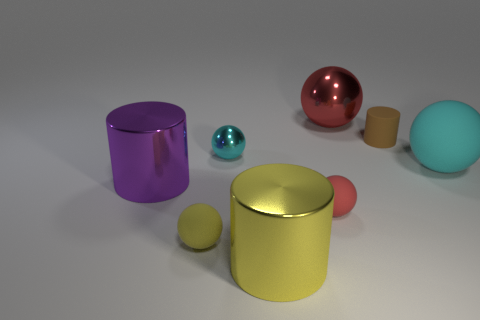What number of objects are tiny blue spheres or metal objects in front of the small cyan sphere?
Your answer should be very brief. 2. Does the tiny red rubber thing that is in front of the big cyan ball have the same shape as the shiny thing that is on the left side of the yellow rubber thing?
Offer a very short reply. No. What number of objects are yellow shiny cylinders or cylinders?
Give a very brief answer. 3. Are there any other things that have the same material as the large red thing?
Ensure brevity in your answer.  Yes. Are there any red cylinders?
Ensure brevity in your answer.  No. Is the large cylinder that is on the left side of the yellow metallic cylinder made of the same material as the yellow cylinder?
Offer a terse response. Yes. Are there any rubber things of the same shape as the red metallic thing?
Offer a terse response. Yes. Are there an equal number of large shiny things that are right of the yellow shiny cylinder and big purple shiny things?
Make the answer very short. Yes. What is the material of the tiny ball on the right side of the yellow thing right of the cyan metal thing?
Offer a terse response. Rubber. What is the shape of the tiny yellow thing?
Offer a terse response. Sphere. 